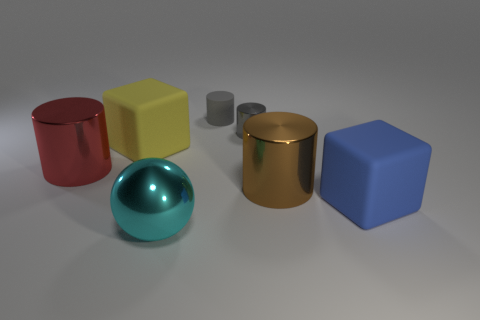What number of balls are either large brown things or small rubber things?
Your answer should be compact. 0. How many large cylinders are on the right side of the thing in front of the large thing that is right of the big brown cylinder?
Your answer should be compact. 1. The metal sphere that is the same size as the yellow thing is what color?
Provide a succinct answer. Cyan. What number of other objects are the same color as the large metal ball?
Offer a very short reply. 0. Is the number of tiny metallic things that are to the right of the gray shiny cylinder greater than the number of yellow balls?
Your answer should be very brief. No. Do the large yellow cube and the brown cylinder have the same material?
Give a very brief answer. No. What number of objects are big things that are in front of the big brown thing or gray objects?
Provide a short and direct response. 4. What number of other objects are the same size as the brown cylinder?
Offer a terse response. 4. Is the number of cyan metal balls in front of the large yellow rubber thing the same as the number of brown metallic cylinders that are on the left side of the brown thing?
Offer a terse response. No. There is another tiny shiny thing that is the same shape as the red thing; what is its color?
Provide a short and direct response. Gray. 